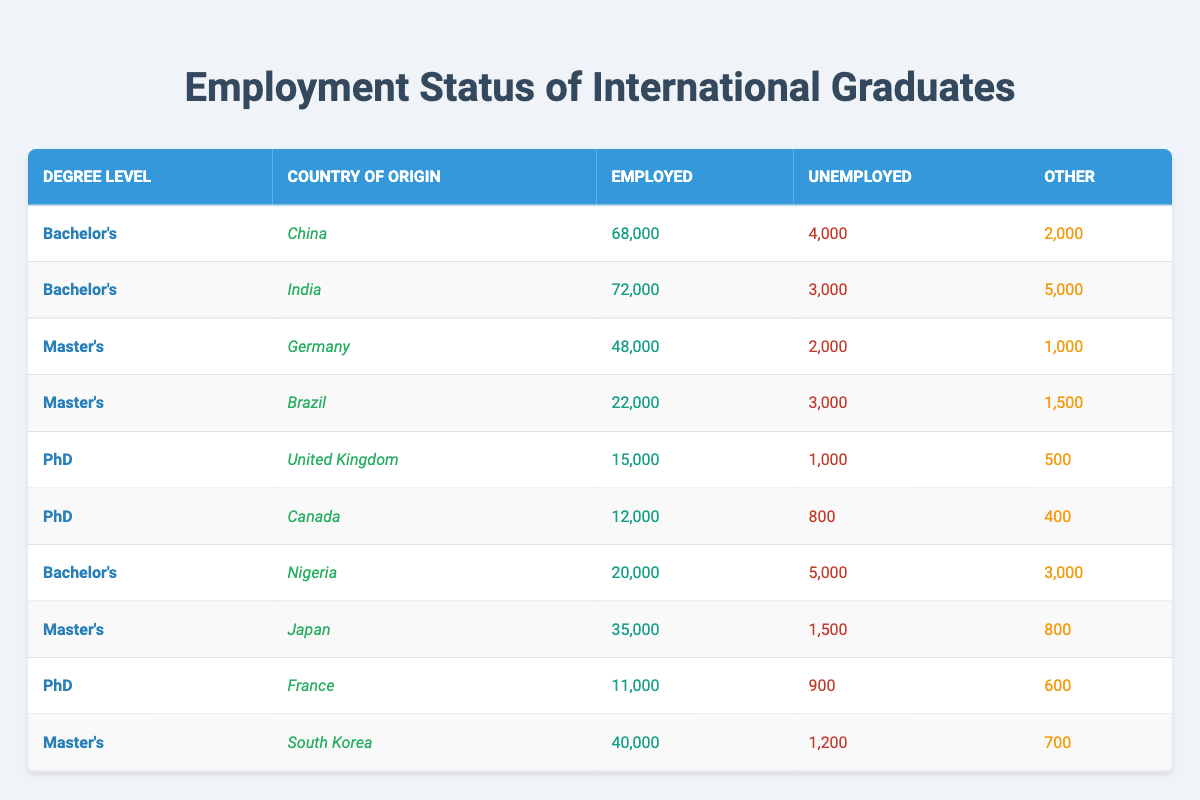What is the total number of employed international graduates from India? From the table, the employed population from India is reported as 72,000. This value can be directly retrieved without any calculations.
Answer: 72,000 How many international graduates from South Korea are unemployed? The unemployment figure for South Korean graduates is directly stated in the table as 1,200. Therefore, this can be answered without additional calculations.
Answer: 1,200 Which country of origin has the highest number of employed graduates at the bachelor's level? By comparing the employed figures from the bachelor's degree rows for China, India, and Nigeria, we see that China has 68,000, India has 72,000, and Nigeria has 20,000. India has the highest employed graduates at the bachelor's level.
Answer: India What is the combined number of unemployed graduates from Germany and Brazil? The unemployed figures for Germany and Brazil are 2,000 and 3,000 respectively. Combining these numbers, 2,000 + 3,000 equals 5,000. Therefore, the total number of unemployed graduates from these two countries is 5,000.
Answer: 5,000 Is it true that all countries listed for PhD graduates have more employed than unemployed individuals? For the UK, the employed figure is 15,000 and unemployed is 1,000, leading to more employed. For Canada, employed is 12,000 and unemployed is 800; again, more employed. For France, employed is 11,000 and unemployed is 900; still more employed. In all cases, the employed number exceeds the unemployed. Thus, the statement is true.
Answer: Yes What is the average number of "other" statuses for master's graduates from Japan, Brazil, and South Korea? The "other" statuses for Japan, Brazil, and South Korea are 800, 1,500, and 700 respectively. First, we sum these values: 800 + 1,500 + 700 equals 3,000. Then, we find the average by dividing by the number of entries (3): 3,000 / 3 equals 1,000.
Answer: 1,000 Which degree level has the highest unemployment number among the listed countries? The unemployment figures for Bachelor’s (4,000 + 3,000 + 5,000 = 12,000), Master's (2,000 + 3,000 + 1,500 + 1,200 = 7,700), and PhD (1,000 + 800 + 900 = 2,700) show that Bachelor’s has the highest, totaling 12,000.
Answer: Bachelor's How many international graduates from the United Kingdom are employed versus unemployed? The employed graduates from the UK are 15,000, while the unemployed graduates are 1,000. This data can be directly found in the table, reflecting both values clearly.
Answer: 15,000 employed, 1,000 unemployed 